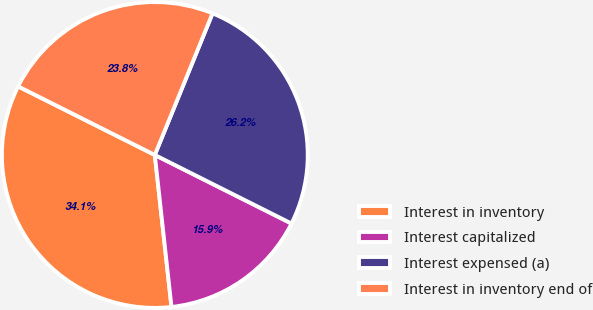Convert chart to OTSL. <chart><loc_0><loc_0><loc_500><loc_500><pie_chart><fcel>Interest in inventory<fcel>Interest capitalized<fcel>Interest expensed (a)<fcel>Interest in inventory end of<nl><fcel>34.14%<fcel>15.86%<fcel>26.24%<fcel>23.76%<nl></chart> 